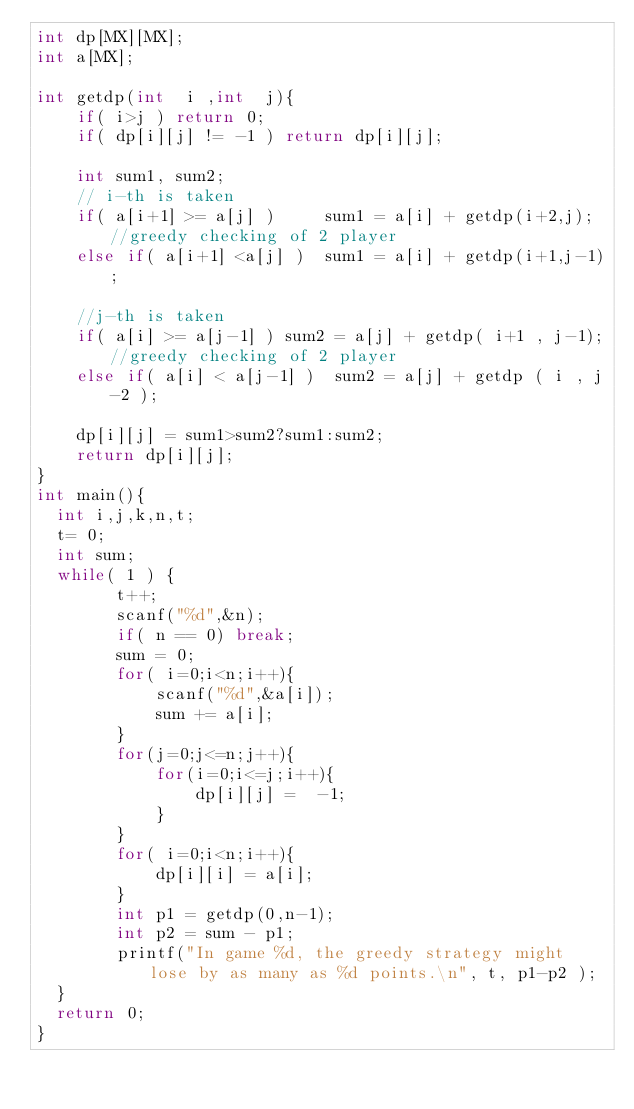Convert code to text. <code><loc_0><loc_0><loc_500><loc_500><_C++_>int dp[MX][MX];
int a[MX];

int getdp(int  i ,int  j){
    if( i>j ) return 0;
    if( dp[i][j] != -1 ) return dp[i][j];

    int sum1, sum2;
    // i-th is taken
    if( a[i+1] >= a[j] )     sum1 = a[i] + getdp(i+2,j); //greedy checking of 2 player
    else if( a[i+1] <a[j] )  sum1 = a[i] + getdp(i+1,j-1);

    //j-th is taken
    if( a[i] >= a[j-1] ) sum2 = a[j] + getdp( i+1 , j-1);//greedy checking of 2 player
    else if( a[i] < a[j-1] )  sum2 = a[j] + getdp ( i , j-2 );

    dp[i][j] = sum1>sum2?sum1:sum2;
    return dp[i][j];
}
int main(){
  int i,j,k,n,t;
  t= 0;
  int sum;
  while( 1 ) {
        t++;
        scanf("%d",&n);
        if( n == 0) break;
        sum = 0;
        for( i=0;i<n;i++){
            scanf("%d",&a[i]);
            sum += a[i];
        }
        for(j=0;j<=n;j++){
            for(i=0;i<=j;i++){
                dp[i][j] =  -1;
            }
        }
        for( i=0;i<n;i++){
            dp[i][i] = a[i];
        }
        int p1 = getdp(0,n-1);
        int p2 = sum - p1;
        printf("In game %d, the greedy strategy might lose by as many as %d points.\n", t, p1-p2 );
  }
  return 0;
}

</code> 